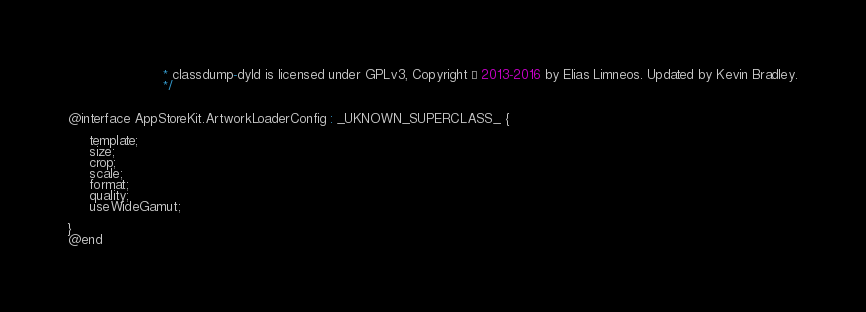<code> <loc_0><loc_0><loc_500><loc_500><_C_>                       * classdump-dyld is licensed under GPLv3, Copyright © 2013-2016 by Elias Limneos. Updated by Kevin Bradley.
                       */


@interface AppStoreKit.ArtworkLoaderConfig : _UKNOWN_SUPERCLASS_ {

	 template;
	 size;
	 crop;
	 scale;
	 format;
	 quality;
	 useWideGamut;

}
@end

</code> 